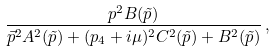<formula> <loc_0><loc_0><loc_500><loc_500>\frac { p ^ { 2 } B ( \tilde { p } ) } { \vec { p } ^ { 2 } A ^ { 2 } ( \tilde { p } ) + ( p _ { 4 } + i \mu ) ^ { 2 } C ^ { 2 } ( \tilde { p } ) + B ^ { 2 } ( \tilde { p } ) } \, ,</formula> 